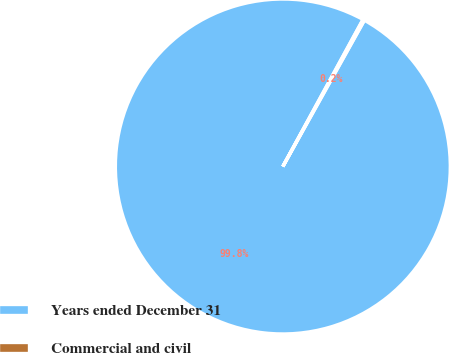Convert chart. <chart><loc_0><loc_0><loc_500><loc_500><pie_chart><fcel>Years ended December 31<fcel>Commercial and civil<nl><fcel>99.85%<fcel>0.15%<nl></chart> 